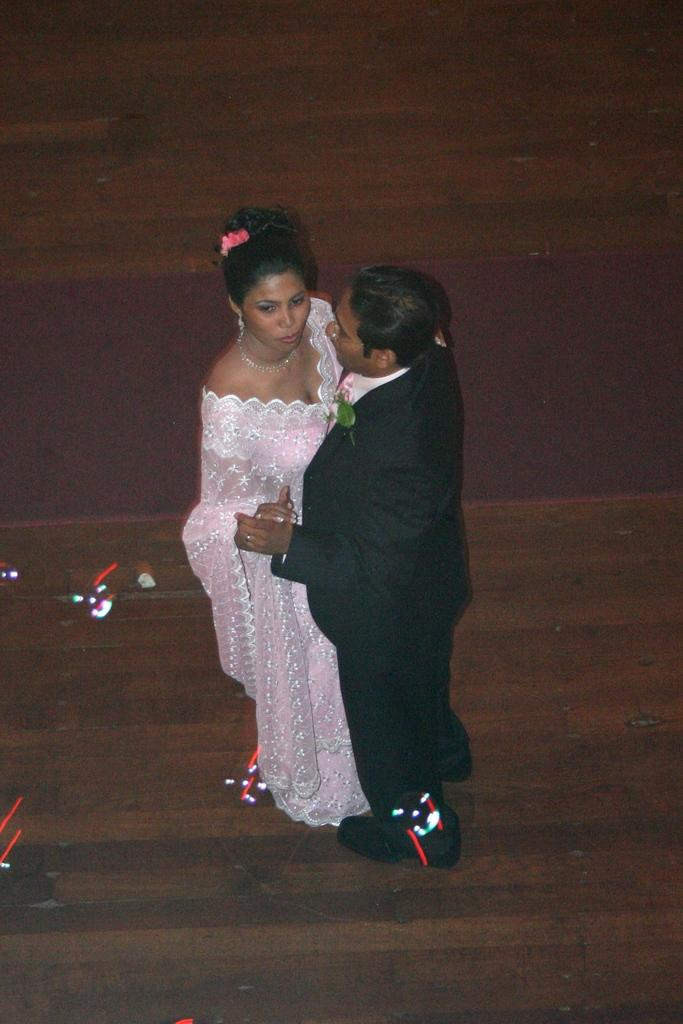Who is present in the image? There is a man and a woman in the image. What are the man and woman doing in the image? The man and woman are holding hands in the image. Where are the man and woman standing in the image? They are standing on the floor in the image. What can be seen on the floor in the image? There is lighting on the floor in the image. What type of polish is being applied to the room in the image? There is no indication of polish or a room in the image; it features a man and a woman holding hands on the floor. 